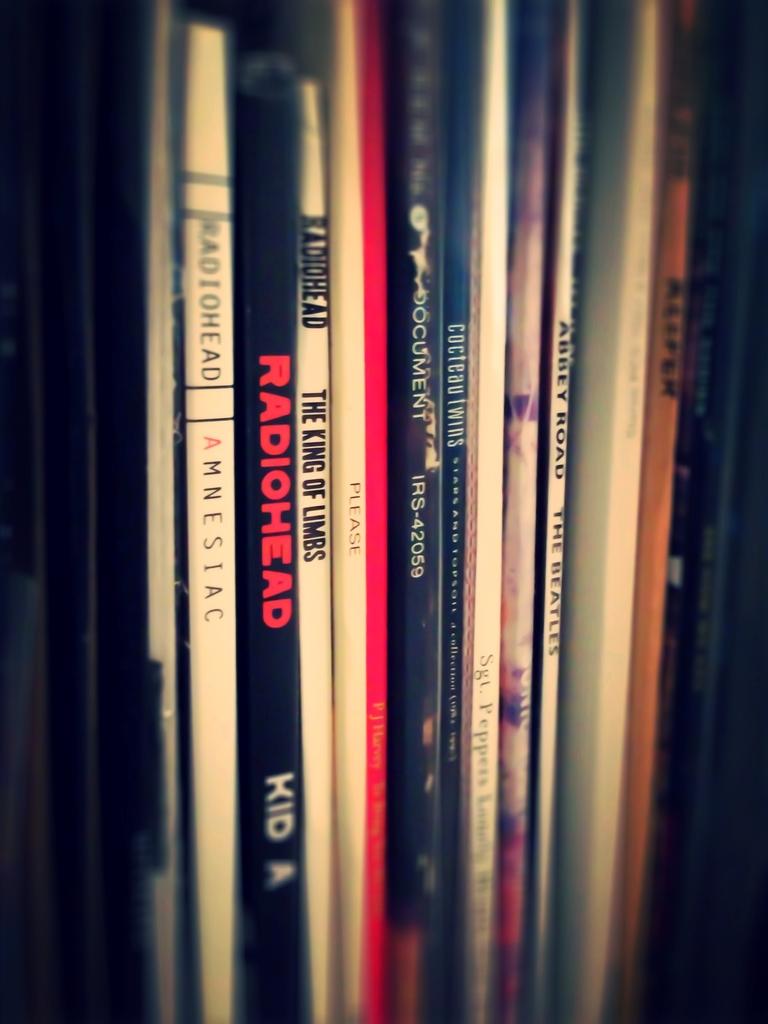Which band write the album kid a?
Ensure brevity in your answer.  Radiohead. 